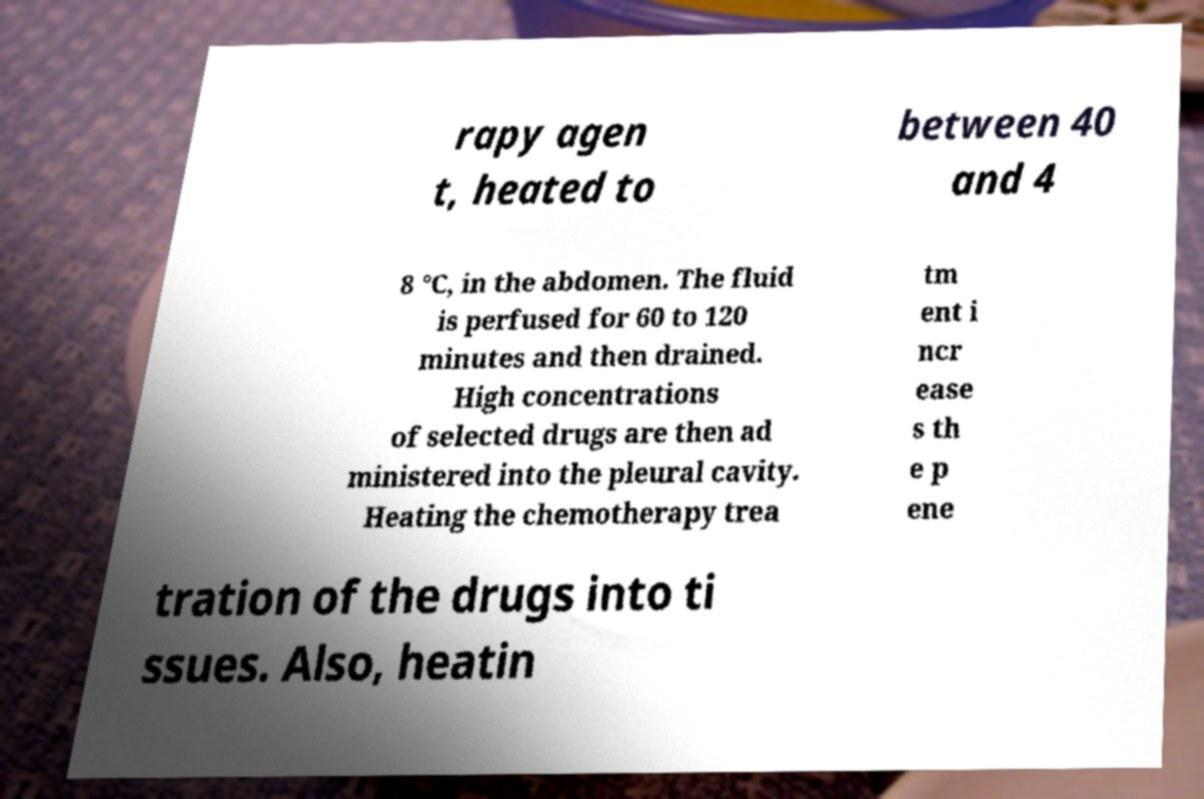What messages or text are displayed in this image? I need them in a readable, typed format. rapy agen t, heated to between 40 and 4 8 °C, in the abdomen. The fluid is perfused for 60 to 120 minutes and then drained. High concentrations of selected drugs are then ad ministered into the pleural cavity. Heating the chemotherapy trea tm ent i ncr ease s th e p ene tration of the drugs into ti ssues. Also, heatin 